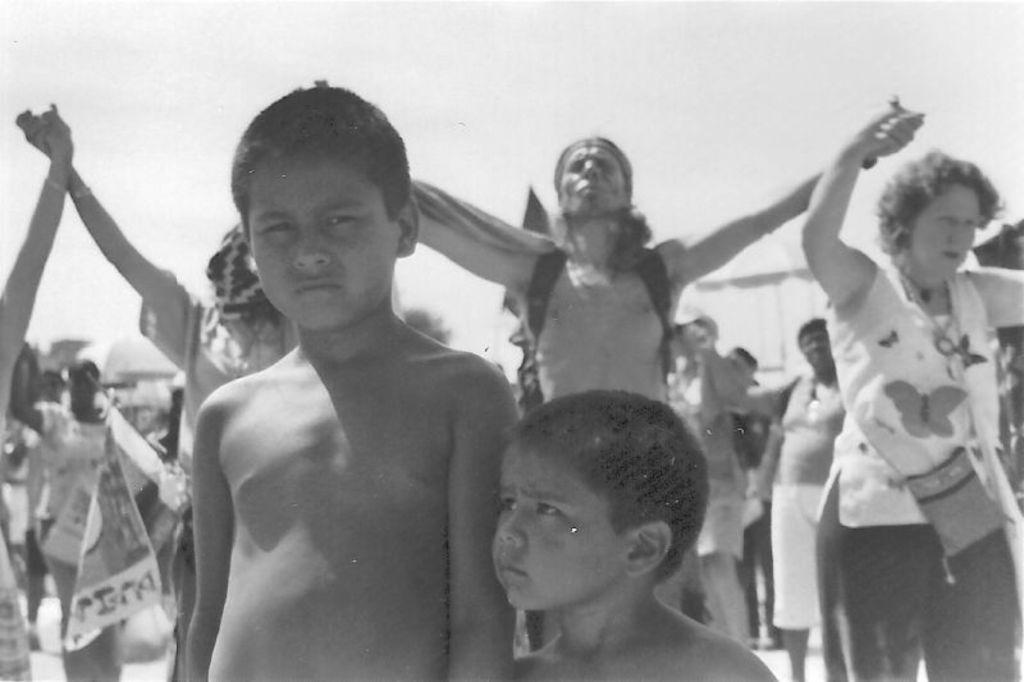What is the color scheme of the image? The image is black and white. Who are the main subjects in the image? There are children in the image. Can you describe the background of the image? There are people in the background of the image, and the sky is visible. What type of basket is being used by the children in the image? There is no basket present in the image. How does the water affect the children's activities in the image? There is no water present in the image, so it does not affect the children's activities. 